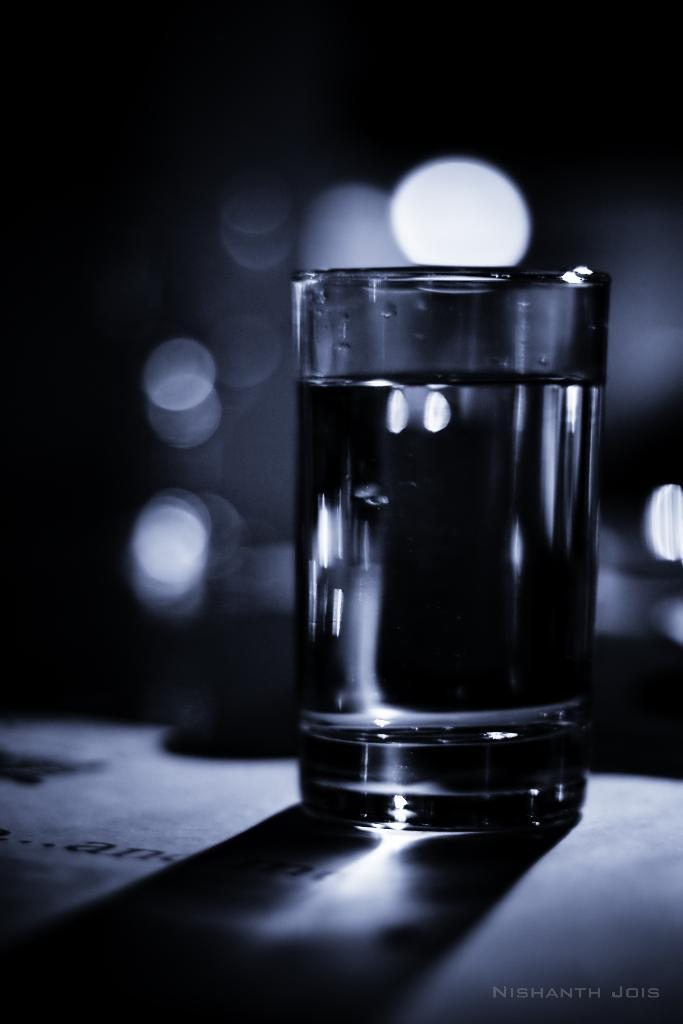What is in the glass that is visible in the image? There is a glass of drink in the image. Can you describe the background of the image? The background of the image is blurry. Where is the text located in the image? The text is at the right bottom of the image. What type of thread is being used to adjust the focus of the image? There is no thread or adjustment of focus visible in the image; it is a still photograph with a blurry background. 